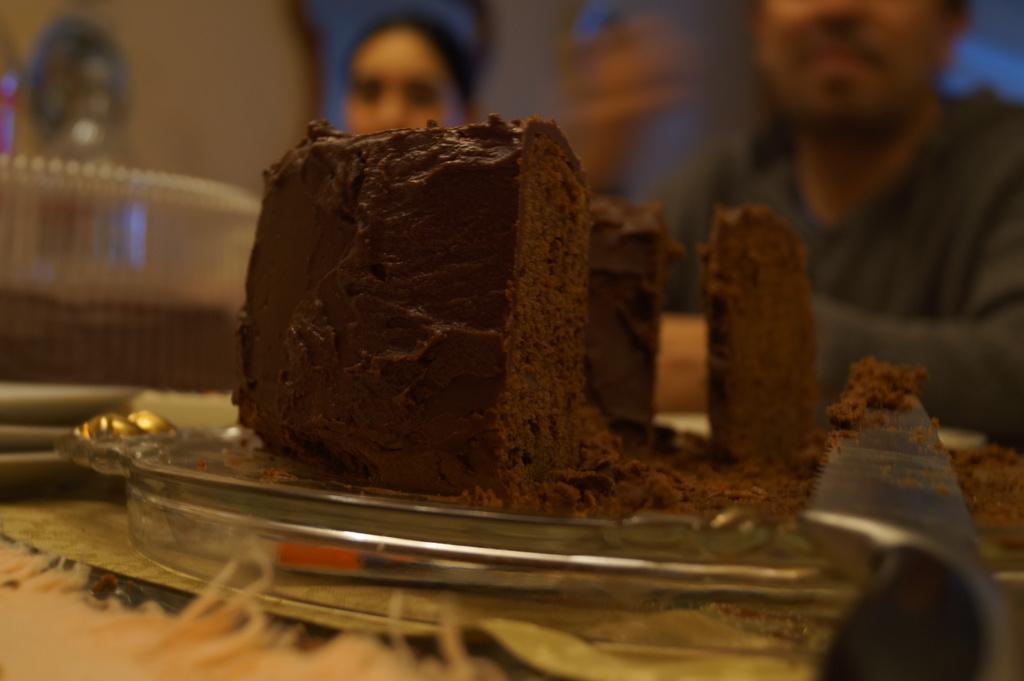In one or two sentences, can you explain what this image depicts? In this picture we can see a plate on an object and on the plate there is a cake and a knife. Behind the cake there are two people and some blurred things. 